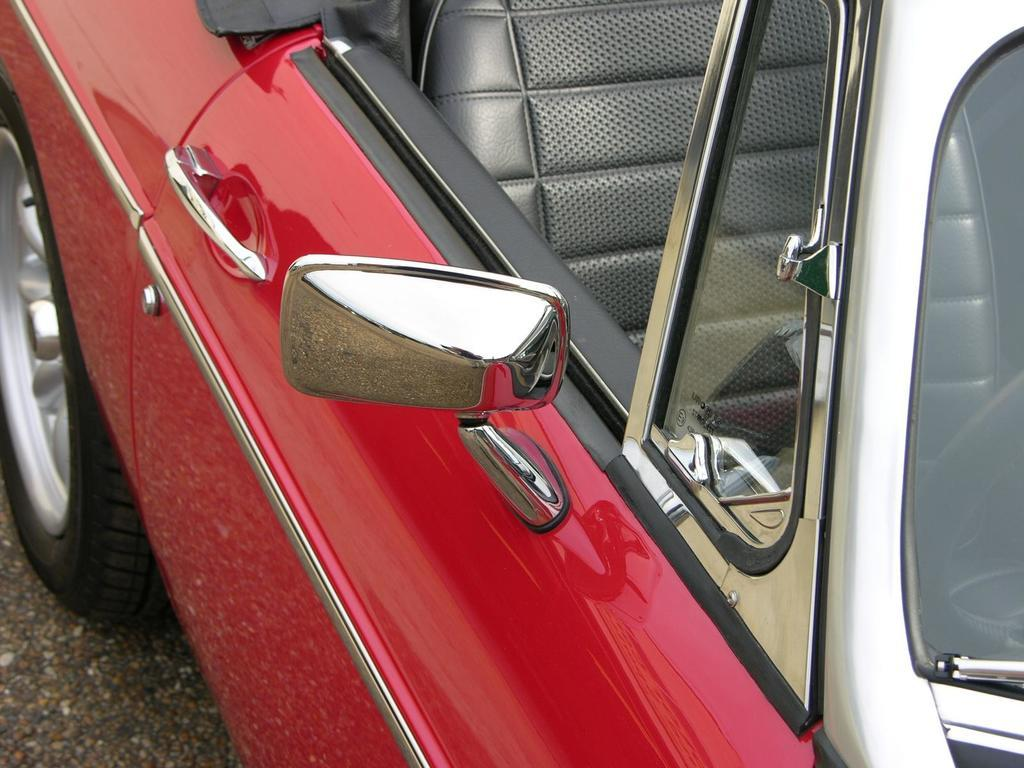What is the main subject of the image? The main subject of the image is a car. What can be said about the color of the car? The car is red in color. Where is the bat hiding in the image? There is no bat present in the image. What type of shade is covering the car in the image? There is no shade visible in the image; the car is exposed to the open air. 